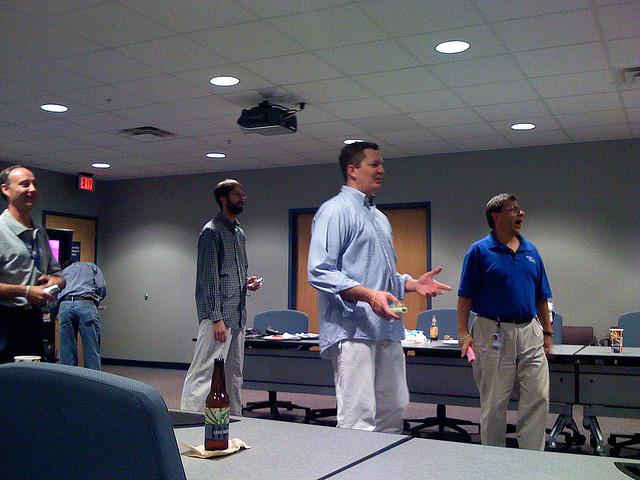What is the purpose of the black object on the ceiling? Please explain your reasoning. projecting. The object on the ceiling is a project and can be used to show movies or games. 